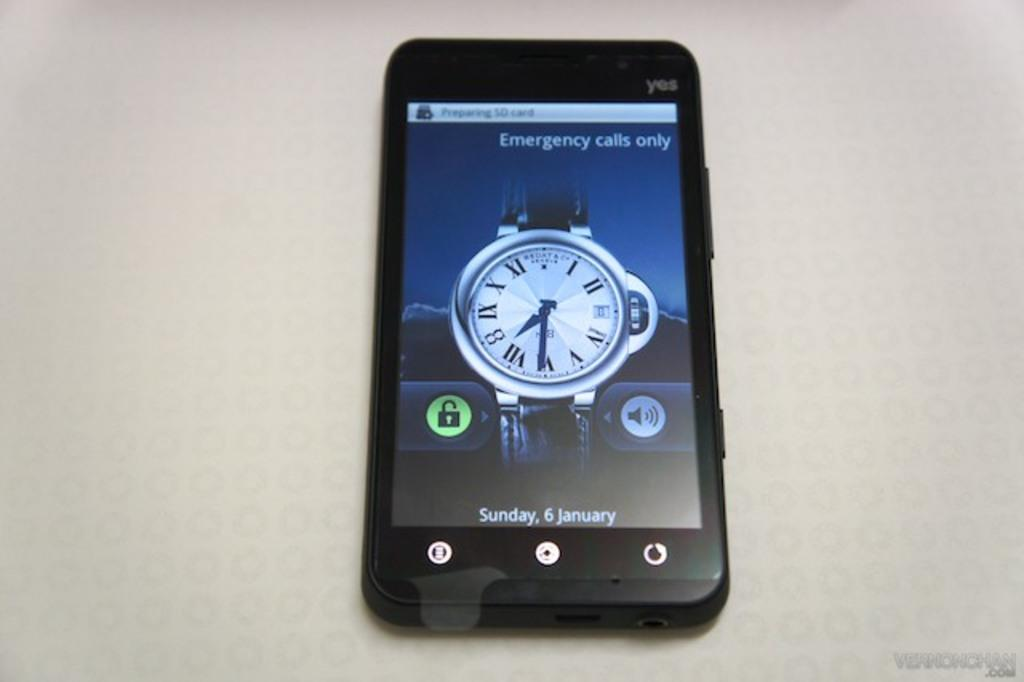<image>
Summarize the visual content of the image. A phone screen displays the text "Emergency calls only." 